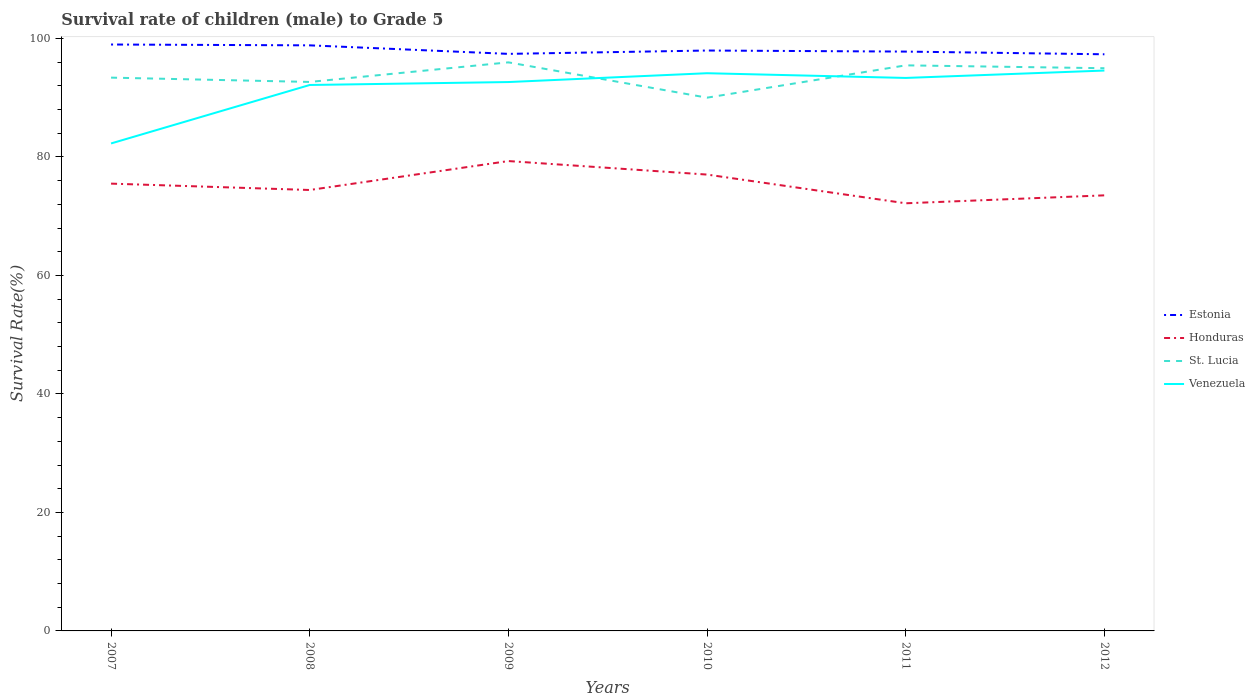Does the line corresponding to Honduras intersect with the line corresponding to Venezuela?
Keep it short and to the point. No. Across all years, what is the maximum survival rate of male children to grade 5 in Honduras?
Your answer should be compact. 72.17. What is the total survival rate of male children to grade 5 in Estonia in the graph?
Keep it short and to the point. 1.44. What is the difference between the highest and the second highest survival rate of male children to grade 5 in Honduras?
Make the answer very short. 7.13. What is the difference between two consecutive major ticks on the Y-axis?
Keep it short and to the point. 20. Are the values on the major ticks of Y-axis written in scientific E-notation?
Ensure brevity in your answer.  No. Does the graph contain grids?
Your answer should be very brief. No. How many legend labels are there?
Your answer should be compact. 4. How are the legend labels stacked?
Your response must be concise. Vertical. What is the title of the graph?
Keep it short and to the point. Survival rate of children (male) to Grade 5. Does "South Asia" appear as one of the legend labels in the graph?
Offer a terse response. No. What is the label or title of the X-axis?
Provide a short and direct response. Years. What is the label or title of the Y-axis?
Provide a short and direct response. Survival Rate(%). What is the Survival Rate(%) in Estonia in 2007?
Make the answer very short. 98.97. What is the Survival Rate(%) in Honduras in 2007?
Provide a succinct answer. 75.49. What is the Survival Rate(%) of St. Lucia in 2007?
Give a very brief answer. 93.38. What is the Survival Rate(%) in Venezuela in 2007?
Offer a very short reply. 82.28. What is the Survival Rate(%) in Estonia in 2008?
Offer a very short reply. 98.83. What is the Survival Rate(%) in Honduras in 2008?
Give a very brief answer. 74.42. What is the Survival Rate(%) of St. Lucia in 2008?
Make the answer very short. 92.65. What is the Survival Rate(%) in Venezuela in 2008?
Your answer should be compact. 92.14. What is the Survival Rate(%) in Estonia in 2009?
Keep it short and to the point. 97.39. What is the Survival Rate(%) in Honduras in 2009?
Offer a terse response. 79.3. What is the Survival Rate(%) in St. Lucia in 2009?
Offer a terse response. 95.96. What is the Survival Rate(%) in Venezuela in 2009?
Your answer should be very brief. 92.64. What is the Survival Rate(%) in Estonia in 2010?
Offer a terse response. 97.96. What is the Survival Rate(%) in Honduras in 2010?
Offer a very short reply. 77.02. What is the Survival Rate(%) of St. Lucia in 2010?
Offer a very short reply. 90. What is the Survival Rate(%) in Venezuela in 2010?
Your answer should be compact. 94.13. What is the Survival Rate(%) in Estonia in 2011?
Offer a very short reply. 97.78. What is the Survival Rate(%) in Honduras in 2011?
Make the answer very short. 72.17. What is the Survival Rate(%) of St. Lucia in 2011?
Your response must be concise. 95.45. What is the Survival Rate(%) in Venezuela in 2011?
Ensure brevity in your answer.  93.33. What is the Survival Rate(%) of Estonia in 2012?
Keep it short and to the point. 97.32. What is the Survival Rate(%) in Honduras in 2012?
Your response must be concise. 73.51. What is the Survival Rate(%) in St. Lucia in 2012?
Give a very brief answer. 94.97. What is the Survival Rate(%) in Venezuela in 2012?
Ensure brevity in your answer.  94.58. Across all years, what is the maximum Survival Rate(%) in Estonia?
Your answer should be very brief. 98.97. Across all years, what is the maximum Survival Rate(%) of Honduras?
Your response must be concise. 79.3. Across all years, what is the maximum Survival Rate(%) of St. Lucia?
Ensure brevity in your answer.  95.96. Across all years, what is the maximum Survival Rate(%) of Venezuela?
Give a very brief answer. 94.58. Across all years, what is the minimum Survival Rate(%) in Estonia?
Your response must be concise. 97.32. Across all years, what is the minimum Survival Rate(%) of Honduras?
Provide a succinct answer. 72.17. Across all years, what is the minimum Survival Rate(%) of St. Lucia?
Offer a very short reply. 90. Across all years, what is the minimum Survival Rate(%) in Venezuela?
Ensure brevity in your answer.  82.28. What is the total Survival Rate(%) of Estonia in the graph?
Give a very brief answer. 588.25. What is the total Survival Rate(%) of Honduras in the graph?
Your answer should be compact. 451.92. What is the total Survival Rate(%) in St. Lucia in the graph?
Provide a succinct answer. 562.42. What is the total Survival Rate(%) of Venezuela in the graph?
Offer a terse response. 549.09. What is the difference between the Survival Rate(%) in Estonia in 2007 and that in 2008?
Your answer should be compact. 0.14. What is the difference between the Survival Rate(%) in Honduras in 2007 and that in 2008?
Your answer should be compact. 1.07. What is the difference between the Survival Rate(%) of St. Lucia in 2007 and that in 2008?
Offer a terse response. 0.73. What is the difference between the Survival Rate(%) in Venezuela in 2007 and that in 2008?
Offer a very short reply. -9.87. What is the difference between the Survival Rate(%) of Estonia in 2007 and that in 2009?
Your answer should be very brief. 1.58. What is the difference between the Survival Rate(%) of Honduras in 2007 and that in 2009?
Keep it short and to the point. -3.81. What is the difference between the Survival Rate(%) of St. Lucia in 2007 and that in 2009?
Provide a succinct answer. -2.58. What is the difference between the Survival Rate(%) of Venezuela in 2007 and that in 2009?
Your answer should be compact. -10.36. What is the difference between the Survival Rate(%) in Estonia in 2007 and that in 2010?
Your answer should be very brief. 1.01. What is the difference between the Survival Rate(%) in Honduras in 2007 and that in 2010?
Your answer should be very brief. -1.53. What is the difference between the Survival Rate(%) in St. Lucia in 2007 and that in 2010?
Ensure brevity in your answer.  3.38. What is the difference between the Survival Rate(%) of Venezuela in 2007 and that in 2010?
Provide a short and direct response. -11.85. What is the difference between the Survival Rate(%) in Estonia in 2007 and that in 2011?
Your answer should be very brief. 1.19. What is the difference between the Survival Rate(%) in Honduras in 2007 and that in 2011?
Your answer should be compact. 3.32. What is the difference between the Survival Rate(%) in St. Lucia in 2007 and that in 2011?
Provide a succinct answer. -2.07. What is the difference between the Survival Rate(%) in Venezuela in 2007 and that in 2011?
Your response must be concise. -11.05. What is the difference between the Survival Rate(%) in Estonia in 2007 and that in 2012?
Offer a terse response. 1.65. What is the difference between the Survival Rate(%) of Honduras in 2007 and that in 2012?
Give a very brief answer. 1.98. What is the difference between the Survival Rate(%) in St. Lucia in 2007 and that in 2012?
Your answer should be very brief. -1.59. What is the difference between the Survival Rate(%) in Venezuela in 2007 and that in 2012?
Ensure brevity in your answer.  -12.3. What is the difference between the Survival Rate(%) of Estonia in 2008 and that in 2009?
Offer a terse response. 1.44. What is the difference between the Survival Rate(%) in Honduras in 2008 and that in 2009?
Your answer should be very brief. -4.88. What is the difference between the Survival Rate(%) in St. Lucia in 2008 and that in 2009?
Provide a succinct answer. -3.31. What is the difference between the Survival Rate(%) of Venezuela in 2008 and that in 2009?
Provide a succinct answer. -0.5. What is the difference between the Survival Rate(%) of Estonia in 2008 and that in 2010?
Your response must be concise. 0.87. What is the difference between the Survival Rate(%) of Honduras in 2008 and that in 2010?
Your answer should be very brief. -2.6. What is the difference between the Survival Rate(%) in St. Lucia in 2008 and that in 2010?
Your answer should be compact. 2.65. What is the difference between the Survival Rate(%) of Venezuela in 2008 and that in 2010?
Your answer should be very brief. -1.99. What is the difference between the Survival Rate(%) in Estonia in 2008 and that in 2011?
Ensure brevity in your answer.  1.05. What is the difference between the Survival Rate(%) in Honduras in 2008 and that in 2011?
Offer a very short reply. 2.24. What is the difference between the Survival Rate(%) of St. Lucia in 2008 and that in 2011?
Keep it short and to the point. -2.8. What is the difference between the Survival Rate(%) of Venezuela in 2008 and that in 2011?
Offer a terse response. -1.19. What is the difference between the Survival Rate(%) in Estonia in 2008 and that in 2012?
Offer a very short reply. 1.51. What is the difference between the Survival Rate(%) of Honduras in 2008 and that in 2012?
Offer a terse response. 0.9. What is the difference between the Survival Rate(%) in St. Lucia in 2008 and that in 2012?
Make the answer very short. -2.31. What is the difference between the Survival Rate(%) of Venezuela in 2008 and that in 2012?
Offer a very short reply. -2.44. What is the difference between the Survival Rate(%) of Estonia in 2009 and that in 2010?
Provide a short and direct response. -0.57. What is the difference between the Survival Rate(%) in Honduras in 2009 and that in 2010?
Your answer should be compact. 2.28. What is the difference between the Survival Rate(%) of St. Lucia in 2009 and that in 2010?
Give a very brief answer. 5.96. What is the difference between the Survival Rate(%) of Venezuela in 2009 and that in 2010?
Give a very brief answer. -1.49. What is the difference between the Survival Rate(%) in Estonia in 2009 and that in 2011?
Your answer should be compact. -0.39. What is the difference between the Survival Rate(%) in Honduras in 2009 and that in 2011?
Your response must be concise. 7.13. What is the difference between the Survival Rate(%) of St. Lucia in 2009 and that in 2011?
Your response must be concise. 0.51. What is the difference between the Survival Rate(%) in Venezuela in 2009 and that in 2011?
Offer a very short reply. -0.69. What is the difference between the Survival Rate(%) of Estonia in 2009 and that in 2012?
Provide a short and direct response. 0.07. What is the difference between the Survival Rate(%) of Honduras in 2009 and that in 2012?
Keep it short and to the point. 5.79. What is the difference between the Survival Rate(%) in Venezuela in 2009 and that in 2012?
Give a very brief answer. -1.94. What is the difference between the Survival Rate(%) of Estonia in 2010 and that in 2011?
Offer a very short reply. 0.18. What is the difference between the Survival Rate(%) of Honduras in 2010 and that in 2011?
Your response must be concise. 4.85. What is the difference between the Survival Rate(%) in St. Lucia in 2010 and that in 2011?
Offer a terse response. -5.45. What is the difference between the Survival Rate(%) of Venezuela in 2010 and that in 2011?
Ensure brevity in your answer.  0.8. What is the difference between the Survival Rate(%) in Estonia in 2010 and that in 2012?
Your answer should be very brief. 0.63. What is the difference between the Survival Rate(%) in Honduras in 2010 and that in 2012?
Offer a terse response. 3.51. What is the difference between the Survival Rate(%) in St. Lucia in 2010 and that in 2012?
Ensure brevity in your answer.  -4.97. What is the difference between the Survival Rate(%) in Venezuela in 2010 and that in 2012?
Your answer should be very brief. -0.45. What is the difference between the Survival Rate(%) in Estonia in 2011 and that in 2012?
Give a very brief answer. 0.46. What is the difference between the Survival Rate(%) of Honduras in 2011 and that in 2012?
Offer a terse response. -1.34. What is the difference between the Survival Rate(%) of St. Lucia in 2011 and that in 2012?
Keep it short and to the point. 0.48. What is the difference between the Survival Rate(%) of Venezuela in 2011 and that in 2012?
Provide a short and direct response. -1.25. What is the difference between the Survival Rate(%) in Estonia in 2007 and the Survival Rate(%) in Honduras in 2008?
Provide a short and direct response. 24.55. What is the difference between the Survival Rate(%) of Estonia in 2007 and the Survival Rate(%) of St. Lucia in 2008?
Keep it short and to the point. 6.32. What is the difference between the Survival Rate(%) in Estonia in 2007 and the Survival Rate(%) in Venezuela in 2008?
Your answer should be compact. 6.83. What is the difference between the Survival Rate(%) in Honduras in 2007 and the Survival Rate(%) in St. Lucia in 2008?
Ensure brevity in your answer.  -17.16. What is the difference between the Survival Rate(%) of Honduras in 2007 and the Survival Rate(%) of Venezuela in 2008?
Your response must be concise. -16.65. What is the difference between the Survival Rate(%) in St. Lucia in 2007 and the Survival Rate(%) in Venezuela in 2008?
Offer a very short reply. 1.24. What is the difference between the Survival Rate(%) of Estonia in 2007 and the Survival Rate(%) of Honduras in 2009?
Keep it short and to the point. 19.67. What is the difference between the Survival Rate(%) in Estonia in 2007 and the Survival Rate(%) in St. Lucia in 2009?
Keep it short and to the point. 3.01. What is the difference between the Survival Rate(%) in Estonia in 2007 and the Survival Rate(%) in Venezuela in 2009?
Offer a very short reply. 6.33. What is the difference between the Survival Rate(%) of Honduras in 2007 and the Survival Rate(%) of St. Lucia in 2009?
Provide a short and direct response. -20.47. What is the difference between the Survival Rate(%) of Honduras in 2007 and the Survival Rate(%) of Venezuela in 2009?
Your answer should be very brief. -17.14. What is the difference between the Survival Rate(%) in St. Lucia in 2007 and the Survival Rate(%) in Venezuela in 2009?
Make the answer very short. 0.74. What is the difference between the Survival Rate(%) in Estonia in 2007 and the Survival Rate(%) in Honduras in 2010?
Provide a succinct answer. 21.95. What is the difference between the Survival Rate(%) in Estonia in 2007 and the Survival Rate(%) in St. Lucia in 2010?
Offer a very short reply. 8.97. What is the difference between the Survival Rate(%) of Estonia in 2007 and the Survival Rate(%) of Venezuela in 2010?
Your response must be concise. 4.84. What is the difference between the Survival Rate(%) in Honduras in 2007 and the Survival Rate(%) in St. Lucia in 2010?
Your answer should be compact. -14.51. What is the difference between the Survival Rate(%) in Honduras in 2007 and the Survival Rate(%) in Venezuela in 2010?
Your answer should be compact. -18.63. What is the difference between the Survival Rate(%) of St. Lucia in 2007 and the Survival Rate(%) of Venezuela in 2010?
Your response must be concise. -0.74. What is the difference between the Survival Rate(%) in Estonia in 2007 and the Survival Rate(%) in Honduras in 2011?
Provide a succinct answer. 26.8. What is the difference between the Survival Rate(%) in Estonia in 2007 and the Survival Rate(%) in St. Lucia in 2011?
Your answer should be very brief. 3.52. What is the difference between the Survival Rate(%) in Estonia in 2007 and the Survival Rate(%) in Venezuela in 2011?
Provide a succinct answer. 5.64. What is the difference between the Survival Rate(%) in Honduras in 2007 and the Survival Rate(%) in St. Lucia in 2011?
Provide a succinct answer. -19.96. What is the difference between the Survival Rate(%) in Honduras in 2007 and the Survival Rate(%) in Venezuela in 2011?
Make the answer very short. -17.84. What is the difference between the Survival Rate(%) in St. Lucia in 2007 and the Survival Rate(%) in Venezuela in 2011?
Your response must be concise. 0.05. What is the difference between the Survival Rate(%) in Estonia in 2007 and the Survival Rate(%) in Honduras in 2012?
Your answer should be very brief. 25.46. What is the difference between the Survival Rate(%) of Estonia in 2007 and the Survival Rate(%) of St. Lucia in 2012?
Provide a short and direct response. 4. What is the difference between the Survival Rate(%) of Estonia in 2007 and the Survival Rate(%) of Venezuela in 2012?
Give a very brief answer. 4.39. What is the difference between the Survival Rate(%) in Honduras in 2007 and the Survival Rate(%) in St. Lucia in 2012?
Keep it short and to the point. -19.48. What is the difference between the Survival Rate(%) of Honduras in 2007 and the Survival Rate(%) of Venezuela in 2012?
Provide a short and direct response. -19.08. What is the difference between the Survival Rate(%) in St. Lucia in 2007 and the Survival Rate(%) in Venezuela in 2012?
Make the answer very short. -1.2. What is the difference between the Survival Rate(%) of Estonia in 2008 and the Survival Rate(%) of Honduras in 2009?
Offer a terse response. 19.53. What is the difference between the Survival Rate(%) of Estonia in 2008 and the Survival Rate(%) of St. Lucia in 2009?
Make the answer very short. 2.87. What is the difference between the Survival Rate(%) in Estonia in 2008 and the Survival Rate(%) in Venezuela in 2009?
Your answer should be very brief. 6.19. What is the difference between the Survival Rate(%) of Honduras in 2008 and the Survival Rate(%) of St. Lucia in 2009?
Make the answer very short. -21.54. What is the difference between the Survival Rate(%) in Honduras in 2008 and the Survival Rate(%) in Venezuela in 2009?
Offer a terse response. -18.22. What is the difference between the Survival Rate(%) in St. Lucia in 2008 and the Survival Rate(%) in Venezuela in 2009?
Your answer should be compact. 0.02. What is the difference between the Survival Rate(%) in Estonia in 2008 and the Survival Rate(%) in Honduras in 2010?
Offer a terse response. 21.81. What is the difference between the Survival Rate(%) in Estonia in 2008 and the Survival Rate(%) in St. Lucia in 2010?
Your response must be concise. 8.83. What is the difference between the Survival Rate(%) of Estonia in 2008 and the Survival Rate(%) of Venezuela in 2010?
Your answer should be very brief. 4.7. What is the difference between the Survival Rate(%) of Honduras in 2008 and the Survival Rate(%) of St. Lucia in 2010?
Offer a terse response. -15.58. What is the difference between the Survival Rate(%) in Honduras in 2008 and the Survival Rate(%) in Venezuela in 2010?
Your response must be concise. -19.71. What is the difference between the Survival Rate(%) of St. Lucia in 2008 and the Survival Rate(%) of Venezuela in 2010?
Offer a very short reply. -1.47. What is the difference between the Survival Rate(%) of Estonia in 2008 and the Survival Rate(%) of Honduras in 2011?
Offer a very short reply. 26.66. What is the difference between the Survival Rate(%) in Estonia in 2008 and the Survival Rate(%) in St. Lucia in 2011?
Offer a very short reply. 3.38. What is the difference between the Survival Rate(%) in Estonia in 2008 and the Survival Rate(%) in Venezuela in 2011?
Keep it short and to the point. 5.5. What is the difference between the Survival Rate(%) in Honduras in 2008 and the Survival Rate(%) in St. Lucia in 2011?
Your answer should be compact. -21.04. What is the difference between the Survival Rate(%) in Honduras in 2008 and the Survival Rate(%) in Venezuela in 2011?
Give a very brief answer. -18.91. What is the difference between the Survival Rate(%) in St. Lucia in 2008 and the Survival Rate(%) in Venezuela in 2011?
Give a very brief answer. -0.68. What is the difference between the Survival Rate(%) of Estonia in 2008 and the Survival Rate(%) of Honduras in 2012?
Your answer should be compact. 25.32. What is the difference between the Survival Rate(%) of Estonia in 2008 and the Survival Rate(%) of St. Lucia in 2012?
Provide a short and direct response. 3.86. What is the difference between the Survival Rate(%) in Estonia in 2008 and the Survival Rate(%) in Venezuela in 2012?
Keep it short and to the point. 4.25. What is the difference between the Survival Rate(%) of Honduras in 2008 and the Survival Rate(%) of St. Lucia in 2012?
Offer a very short reply. -20.55. What is the difference between the Survival Rate(%) in Honduras in 2008 and the Survival Rate(%) in Venezuela in 2012?
Your answer should be compact. -20.16. What is the difference between the Survival Rate(%) of St. Lucia in 2008 and the Survival Rate(%) of Venezuela in 2012?
Offer a terse response. -1.92. What is the difference between the Survival Rate(%) in Estonia in 2009 and the Survival Rate(%) in Honduras in 2010?
Your response must be concise. 20.37. What is the difference between the Survival Rate(%) of Estonia in 2009 and the Survival Rate(%) of St. Lucia in 2010?
Your answer should be very brief. 7.39. What is the difference between the Survival Rate(%) in Estonia in 2009 and the Survival Rate(%) in Venezuela in 2010?
Ensure brevity in your answer.  3.26. What is the difference between the Survival Rate(%) in Honduras in 2009 and the Survival Rate(%) in St. Lucia in 2010?
Give a very brief answer. -10.7. What is the difference between the Survival Rate(%) of Honduras in 2009 and the Survival Rate(%) of Venezuela in 2010?
Provide a succinct answer. -14.83. What is the difference between the Survival Rate(%) of St. Lucia in 2009 and the Survival Rate(%) of Venezuela in 2010?
Provide a short and direct response. 1.83. What is the difference between the Survival Rate(%) in Estonia in 2009 and the Survival Rate(%) in Honduras in 2011?
Your response must be concise. 25.22. What is the difference between the Survival Rate(%) of Estonia in 2009 and the Survival Rate(%) of St. Lucia in 2011?
Offer a very short reply. 1.94. What is the difference between the Survival Rate(%) in Estonia in 2009 and the Survival Rate(%) in Venezuela in 2011?
Provide a short and direct response. 4.06. What is the difference between the Survival Rate(%) in Honduras in 2009 and the Survival Rate(%) in St. Lucia in 2011?
Provide a short and direct response. -16.15. What is the difference between the Survival Rate(%) of Honduras in 2009 and the Survival Rate(%) of Venezuela in 2011?
Your response must be concise. -14.03. What is the difference between the Survival Rate(%) in St. Lucia in 2009 and the Survival Rate(%) in Venezuela in 2011?
Offer a terse response. 2.63. What is the difference between the Survival Rate(%) of Estonia in 2009 and the Survival Rate(%) of Honduras in 2012?
Your answer should be compact. 23.88. What is the difference between the Survival Rate(%) in Estonia in 2009 and the Survival Rate(%) in St. Lucia in 2012?
Your answer should be compact. 2.42. What is the difference between the Survival Rate(%) of Estonia in 2009 and the Survival Rate(%) of Venezuela in 2012?
Ensure brevity in your answer.  2.81. What is the difference between the Survival Rate(%) in Honduras in 2009 and the Survival Rate(%) in St. Lucia in 2012?
Offer a very short reply. -15.67. What is the difference between the Survival Rate(%) in Honduras in 2009 and the Survival Rate(%) in Venezuela in 2012?
Offer a terse response. -15.28. What is the difference between the Survival Rate(%) of St. Lucia in 2009 and the Survival Rate(%) of Venezuela in 2012?
Your answer should be compact. 1.38. What is the difference between the Survival Rate(%) in Estonia in 2010 and the Survival Rate(%) in Honduras in 2011?
Provide a short and direct response. 25.78. What is the difference between the Survival Rate(%) in Estonia in 2010 and the Survival Rate(%) in St. Lucia in 2011?
Provide a succinct answer. 2.5. What is the difference between the Survival Rate(%) in Estonia in 2010 and the Survival Rate(%) in Venezuela in 2011?
Ensure brevity in your answer.  4.63. What is the difference between the Survival Rate(%) in Honduras in 2010 and the Survival Rate(%) in St. Lucia in 2011?
Your answer should be compact. -18.43. What is the difference between the Survival Rate(%) of Honduras in 2010 and the Survival Rate(%) of Venezuela in 2011?
Make the answer very short. -16.31. What is the difference between the Survival Rate(%) of St. Lucia in 2010 and the Survival Rate(%) of Venezuela in 2011?
Give a very brief answer. -3.33. What is the difference between the Survival Rate(%) of Estonia in 2010 and the Survival Rate(%) of Honduras in 2012?
Provide a succinct answer. 24.44. What is the difference between the Survival Rate(%) in Estonia in 2010 and the Survival Rate(%) in St. Lucia in 2012?
Keep it short and to the point. 2.99. What is the difference between the Survival Rate(%) in Estonia in 2010 and the Survival Rate(%) in Venezuela in 2012?
Offer a very short reply. 3.38. What is the difference between the Survival Rate(%) of Honduras in 2010 and the Survival Rate(%) of St. Lucia in 2012?
Offer a very short reply. -17.95. What is the difference between the Survival Rate(%) of Honduras in 2010 and the Survival Rate(%) of Venezuela in 2012?
Provide a succinct answer. -17.56. What is the difference between the Survival Rate(%) of St. Lucia in 2010 and the Survival Rate(%) of Venezuela in 2012?
Make the answer very short. -4.58. What is the difference between the Survival Rate(%) in Estonia in 2011 and the Survival Rate(%) in Honduras in 2012?
Ensure brevity in your answer.  24.26. What is the difference between the Survival Rate(%) of Estonia in 2011 and the Survival Rate(%) of St. Lucia in 2012?
Your response must be concise. 2.81. What is the difference between the Survival Rate(%) in Estonia in 2011 and the Survival Rate(%) in Venezuela in 2012?
Offer a very short reply. 3.2. What is the difference between the Survival Rate(%) of Honduras in 2011 and the Survival Rate(%) of St. Lucia in 2012?
Offer a very short reply. -22.8. What is the difference between the Survival Rate(%) of Honduras in 2011 and the Survival Rate(%) of Venezuela in 2012?
Provide a succinct answer. -22.4. What is the difference between the Survival Rate(%) of St. Lucia in 2011 and the Survival Rate(%) of Venezuela in 2012?
Keep it short and to the point. 0.88. What is the average Survival Rate(%) in Estonia per year?
Your response must be concise. 98.04. What is the average Survival Rate(%) in Honduras per year?
Offer a very short reply. 75.32. What is the average Survival Rate(%) of St. Lucia per year?
Make the answer very short. 93.74. What is the average Survival Rate(%) of Venezuela per year?
Provide a short and direct response. 91.51. In the year 2007, what is the difference between the Survival Rate(%) in Estonia and Survival Rate(%) in Honduras?
Your answer should be compact. 23.48. In the year 2007, what is the difference between the Survival Rate(%) in Estonia and Survival Rate(%) in St. Lucia?
Your answer should be compact. 5.59. In the year 2007, what is the difference between the Survival Rate(%) of Estonia and Survival Rate(%) of Venezuela?
Your answer should be very brief. 16.7. In the year 2007, what is the difference between the Survival Rate(%) in Honduras and Survival Rate(%) in St. Lucia?
Provide a succinct answer. -17.89. In the year 2007, what is the difference between the Survival Rate(%) of Honduras and Survival Rate(%) of Venezuela?
Your answer should be compact. -6.78. In the year 2007, what is the difference between the Survival Rate(%) of St. Lucia and Survival Rate(%) of Venezuela?
Make the answer very short. 11.11. In the year 2008, what is the difference between the Survival Rate(%) of Estonia and Survival Rate(%) of Honduras?
Ensure brevity in your answer.  24.41. In the year 2008, what is the difference between the Survival Rate(%) in Estonia and Survival Rate(%) in St. Lucia?
Your answer should be very brief. 6.18. In the year 2008, what is the difference between the Survival Rate(%) in Estonia and Survival Rate(%) in Venezuela?
Provide a succinct answer. 6.69. In the year 2008, what is the difference between the Survival Rate(%) in Honduras and Survival Rate(%) in St. Lucia?
Offer a terse response. -18.24. In the year 2008, what is the difference between the Survival Rate(%) in Honduras and Survival Rate(%) in Venezuela?
Offer a very short reply. -17.72. In the year 2008, what is the difference between the Survival Rate(%) in St. Lucia and Survival Rate(%) in Venezuela?
Your answer should be very brief. 0.51. In the year 2009, what is the difference between the Survival Rate(%) in Estonia and Survival Rate(%) in Honduras?
Your answer should be very brief. 18.09. In the year 2009, what is the difference between the Survival Rate(%) of Estonia and Survival Rate(%) of St. Lucia?
Offer a terse response. 1.43. In the year 2009, what is the difference between the Survival Rate(%) of Estonia and Survival Rate(%) of Venezuela?
Your response must be concise. 4.75. In the year 2009, what is the difference between the Survival Rate(%) in Honduras and Survival Rate(%) in St. Lucia?
Provide a short and direct response. -16.66. In the year 2009, what is the difference between the Survival Rate(%) of Honduras and Survival Rate(%) of Venezuela?
Your answer should be compact. -13.34. In the year 2009, what is the difference between the Survival Rate(%) in St. Lucia and Survival Rate(%) in Venezuela?
Provide a succinct answer. 3.32. In the year 2010, what is the difference between the Survival Rate(%) of Estonia and Survival Rate(%) of Honduras?
Offer a terse response. 20.94. In the year 2010, what is the difference between the Survival Rate(%) in Estonia and Survival Rate(%) in St. Lucia?
Your answer should be very brief. 7.96. In the year 2010, what is the difference between the Survival Rate(%) in Estonia and Survival Rate(%) in Venezuela?
Provide a succinct answer. 3.83. In the year 2010, what is the difference between the Survival Rate(%) of Honduras and Survival Rate(%) of St. Lucia?
Make the answer very short. -12.98. In the year 2010, what is the difference between the Survival Rate(%) of Honduras and Survival Rate(%) of Venezuela?
Provide a succinct answer. -17.11. In the year 2010, what is the difference between the Survival Rate(%) in St. Lucia and Survival Rate(%) in Venezuela?
Offer a terse response. -4.13. In the year 2011, what is the difference between the Survival Rate(%) of Estonia and Survival Rate(%) of Honduras?
Ensure brevity in your answer.  25.6. In the year 2011, what is the difference between the Survival Rate(%) of Estonia and Survival Rate(%) of St. Lucia?
Your answer should be very brief. 2.32. In the year 2011, what is the difference between the Survival Rate(%) of Estonia and Survival Rate(%) of Venezuela?
Provide a short and direct response. 4.45. In the year 2011, what is the difference between the Survival Rate(%) of Honduras and Survival Rate(%) of St. Lucia?
Provide a succinct answer. -23.28. In the year 2011, what is the difference between the Survival Rate(%) of Honduras and Survival Rate(%) of Venezuela?
Offer a very short reply. -21.16. In the year 2011, what is the difference between the Survival Rate(%) of St. Lucia and Survival Rate(%) of Venezuela?
Ensure brevity in your answer.  2.12. In the year 2012, what is the difference between the Survival Rate(%) in Estonia and Survival Rate(%) in Honduras?
Offer a terse response. 23.81. In the year 2012, what is the difference between the Survival Rate(%) in Estonia and Survival Rate(%) in St. Lucia?
Make the answer very short. 2.35. In the year 2012, what is the difference between the Survival Rate(%) of Estonia and Survival Rate(%) of Venezuela?
Provide a succinct answer. 2.75. In the year 2012, what is the difference between the Survival Rate(%) in Honduras and Survival Rate(%) in St. Lucia?
Your response must be concise. -21.46. In the year 2012, what is the difference between the Survival Rate(%) of Honduras and Survival Rate(%) of Venezuela?
Give a very brief answer. -21.06. In the year 2012, what is the difference between the Survival Rate(%) in St. Lucia and Survival Rate(%) in Venezuela?
Your answer should be compact. 0.39. What is the ratio of the Survival Rate(%) in Honduras in 2007 to that in 2008?
Give a very brief answer. 1.01. What is the ratio of the Survival Rate(%) in Venezuela in 2007 to that in 2008?
Give a very brief answer. 0.89. What is the ratio of the Survival Rate(%) in Estonia in 2007 to that in 2009?
Ensure brevity in your answer.  1.02. What is the ratio of the Survival Rate(%) of Honduras in 2007 to that in 2009?
Provide a short and direct response. 0.95. What is the ratio of the Survival Rate(%) of St. Lucia in 2007 to that in 2009?
Offer a terse response. 0.97. What is the ratio of the Survival Rate(%) in Venezuela in 2007 to that in 2009?
Provide a short and direct response. 0.89. What is the ratio of the Survival Rate(%) of Estonia in 2007 to that in 2010?
Your response must be concise. 1.01. What is the ratio of the Survival Rate(%) of Honduras in 2007 to that in 2010?
Give a very brief answer. 0.98. What is the ratio of the Survival Rate(%) of St. Lucia in 2007 to that in 2010?
Your answer should be compact. 1.04. What is the ratio of the Survival Rate(%) of Venezuela in 2007 to that in 2010?
Provide a succinct answer. 0.87. What is the ratio of the Survival Rate(%) of Estonia in 2007 to that in 2011?
Your response must be concise. 1.01. What is the ratio of the Survival Rate(%) of Honduras in 2007 to that in 2011?
Your answer should be compact. 1.05. What is the ratio of the Survival Rate(%) in St. Lucia in 2007 to that in 2011?
Give a very brief answer. 0.98. What is the ratio of the Survival Rate(%) of Venezuela in 2007 to that in 2011?
Keep it short and to the point. 0.88. What is the ratio of the Survival Rate(%) in Estonia in 2007 to that in 2012?
Make the answer very short. 1.02. What is the ratio of the Survival Rate(%) in Honduras in 2007 to that in 2012?
Provide a succinct answer. 1.03. What is the ratio of the Survival Rate(%) in St. Lucia in 2007 to that in 2012?
Give a very brief answer. 0.98. What is the ratio of the Survival Rate(%) in Venezuela in 2007 to that in 2012?
Keep it short and to the point. 0.87. What is the ratio of the Survival Rate(%) of Estonia in 2008 to that in 2009?
Keep it short and to the point. 1.01. What is the ratio of the Survival Rate(%) in Honduras in 2008 to that in 2009?
Your answer should be very brief. 0.94. What is the ratio of the Survival Rate(%) in St. Lucia in 2008 to that in 2009?
Give a very brief answer. 0.97. What is the ratio of the Survival Rate(%) in Venezuela in 2008 to that in 2009?
Provide a succinct answer. 0.99. What is the ratio of the Survival Rate(%) in Estonia in 2008 to that in 2010?
Your answer should be compact. 1.01. What is the ratio of the Survival Rate(%) in Honduras in 2008 to that in 2010?
Your answer should be very brief. 0.97. What is the ratio of the Survival Rate(%) in St. Lucia in 2008 to that in 2010?
Make the answer very short. 1.03. What is the ratio of the Survival Rate(%) of Venezuela in 2008 to that in 2010?
Provide a succinct answer. 0.98. What is the ratio of the Survival Rate(%) in Estonia in 2008 to that in 2011?
Provide a succinct answer. 1.01. What is the ratio of the Survival Rate(%) in Honduras in 2008 to that in 2011?
Provide a succinct answer. 1.03. What is the ratio of the Survival Rate(%) in St. Lucia in 2008 to that in 2011?
Your answer should be very brief. 0.97. What is the ratio of the Survival Rate(%) in Venezuela in 2008 to that in 2011?
Offer a very short reply. 0.99. What is the ratio of the Survival Rate(%) of Estonia in 2008 to that in 2012?
Your response must be concise. 1.02. What is the ratio of the Survival Rate(%) in Honduras in 2008 to that in 2012?
Offer a very short reply. 1.01. What is the ratio of the Survival Rate(%) of St. Lucia in 2008 to that in 2012?
Your response must be concise. 0.98. What is the ratio of the Survival Rate(%) in Venezuela in 2008 to that in 2012?
Provide a short and direct response. 0.97. What is the ratio of the Survival Rate(%) of Honduras in 2009 to that in 2010?
Provide a short and direct response. 1.03. What is the ratio of the Survival Rate(%) in St. Lucia in 2009 to that in 2010?
Make the answer very short. 1.07. What is the ratio of the Survival Rate(%) of Venezuela in 2009 to that in 2010?
Your answer should be very brief. 0.98. What is the ratio of the Survival Rate(%) of Honduras in 2009 to that in 2011?
Ensure brevity in your answer.  1.1. What is the ratio of the Survival Rate(%) in Venezuela in 2009 to that in 2011?
Offer a very short reply. 0.99. What is the ratio of the Survival Rate(%) in Honduras in 2009 to that in 2012?
Give a very brief answer. 1.08. What is the ratio of the Survival Rate(%) in St. Lucia in 2009 to that in 2012?
Keep it short and to the point. 1.01. What is the ratio of the Survival Rate(%) in Venezuela in 2009 to that in 2012?
Give a very brief answer. 0.98. What is the ratio of the Survival Rate(%) of Estonia in 2010 to that in 2011?
Make the answer very short. 1. What is the ratio of the Survival Rate(%) of Honduras in 2010 to that in 2011?
Your response must be concise. 1.07. What is the ratio of the Survival Rate(%) of St. Lucia in 2010 to that in 2011?
Your answer should be very brief. 0.94. What is the ratio of the Survival Rate(%) in Venezuela in 2010 to that in 2011?
Your response must be concise. 1.01. What is the ratio of the Survival Rate(%) of Honduras in 2010 to that in 2012?
Offer a terse response. 1.05. What is the ratio of the Survival Rate(%) in St. Lucia in 2010 to that in 2012?
Offer a terse response. 0.95. What is the ratio of the Survival Rate(%) of Venezuela in 2010 to that in 2012?
Provide a short and direct response. 1. What is the ratio of the Survival Rate(%) in Estonia in 2011 to that in 2012?
Offer a very short reply. 1. What is the ratio of the Survival Rate(%) in Honduras in 2011 to that in 2012?
Provide a succinct answer. 0.98. What is the ratio of the Survival Rate(%) of Venezuela in 2011 to that in 2012?
Provide a short and direct response. 0.99. What is the difference between the highest and the second highest Survival Rate(%) in Estonia?
Provide a succinct answer. 0.14. What is the difference between the highest and the second highest Survival Rate(%) in Honduras?
Give a very brief answer. 2.28. What is the difference between the highest and the second highest Survival Rate(%) in St. Lucia?
Your answer should be very brief. 0.51. What is the difference between the highest and the second highest Survival Rate(%) in Venezuela?
Make the answer very short. 0.45. What is the difference between the highest and the lowest Survival Rate(%) of Estonia?
Provide a short and direct response. 1.65. What is the difference between the highest and the lowest Survival Rate(%) of Honduras?
Your answer should be compact. 7.13. What is the difference between the highest and the lowest Survival Rate(%) of St. Lucia?
Make the answer very short. 5.96. What is the difference between the highest and the lowest Survival Rate(%) in Venezuela?
Keep it short and to the point. 12.3. 